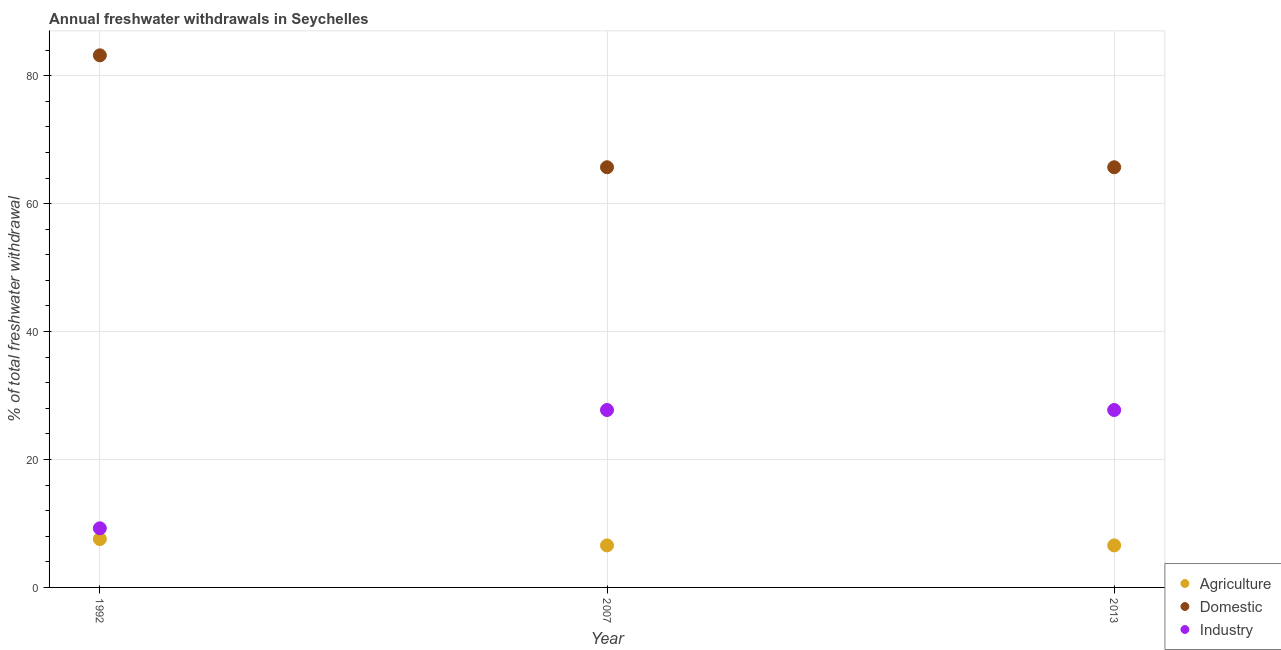Is the number of dotlines equal to the number of legend labels?
Provide a succinct answer. Yes. What is the percentage of freshwater withdrawal for domestic purposes in 2007?
Provide a succinct answer. 65.69. Across all years, what is the maximum percentage of freshwater withdrawal for industry?
Offer a very short reply. 27.74. Across all years, what is the minimum percentage of freshwater withdrawal for agriculture?
Offer a very short reply. 6.57. In which year was the percentage of freshwater withdrawal for domestic purposes maximum?
Provide a short and direct response. 1992. In which year was the percentage of freshwater withdrawal for domestic purposes minimum?
Ensure brevity in your answer.  2007. What is the total percentage of freshwater withdrawal for agriculture in the graph?
Ensure brevity in your answer.  20.7. What is the difference between the percentage of freshwater withdrawal for industry in 1992 and that in 2013?
Your answer should be very brief. -18.5. What is the difference between the percentage of freshwater withdrawal for domestic purposes in 2007 and the percentage of freshwater withdrawal for industry in 1992?
Your answer should be compact. 56.45. What is the average percentage of freshwater withdrawal for industry per year?
Make the answer very short. 21.57. In the year 2007, what is the difference between the percentage of freshwater withdrawal for agriculture and percentage of freshwater withdrawal for industry?
Your answer should be compact. -21.17. What is the ratio of the percentage of freshwater withdrawal for domestic purposes in 1992 to that in 2007?
Provide a succinct answer. 1.27. Is the percentage of freshwater withdrawal for industry in 2007 less than that in 2013?
Keep it short and to the point. No. What is the difference between the highest and the second highest percentage of freshwater withdrawal for agriculture?
Make the answer very short. 0.99. What is the difference between the highest and the lowest percentage of freshwater withdrawal for agriculture?
Provide a succinct answer. 0.99. Is the sum of the percentage of freshwater withdrawal for domestic purposes in 1992 and 2007 greater than the maximum percentage of freshwater withdrawal for agriculture across all years?
Your response must be concise. Yes. Is the percentage of freshwater withdrawal for domestic purposes strictly less than the percentage of freshwater withdrawal for agriculture over the years?
Offer a very short reply. No. Does the graph contain any zero values?
Keep it short and to the point. No. What is the title of the graph?
Provide a succinct answer. Annual freshwater withdrawals in Seychelles. Does "Food" appear as one of the legend labels in the graph?
Give a very brief answer. No. What is the label or title of the X-axis?
Provide a short and direct response. Year. What is the label or title of the Y-axis?
Provide a short and direct response. % of total freshwater withdrawal. What is the % of total freshwater withdrawal of Agriculture in 1992?
Ensure brevity in your answer.  7.56. What is the % of total freshwater withdrawal in Domestic in 1992?
Keep it short and to the point. 83.19. What is the % of total freshwater withdrawal in Industry in 1992?
Ensure brevity in your answer.  9.24. What is the % of total freshwater withdrawal in Agriculture in 2007?
Provide a succinct answer. 6.57. What is the % of total freshwater withdrawal of Domestic in 2007?
Your answer should be very brief. 65.69. What is the % of total freshwater withdrawal in Industry in 2007?
Provide a short and direct response. 27.74. What is the % of total freshwater withdrawal in Agriculture in 2013?
Your response must be concise. 6.57. What is the % of total freshwater withdrawal of Domestic in 2013?
Ensure brevity in your answer.  65.69. What is the % of total freshwater withdrawal of Industry in 2013?
Offer a very short reply. 27.74. Across all years, what is the maximum % of total freshwater withdrawal in Agriculture?
Ensure brevity in your answer.  7.56. Across all years, what is the maximum % of total freshwater withdrawal in Domestic?
Offer a very short reply. 83.19. Across all years, what is the maximum % of total freshwater withdrawal of Industry?
Provide a succinct answer. 27.74. Across all years, what is the minimum % of total freshwater withdrawal in Agriculture?
Keep it short and to the point. 6.57. Across all years, what is the minimum % of total freshwater withdrawal in Domestic?
Make the answer very short. 65.69. Across all years, what is the minimum % of total freshwater withdrawal in Industry?
Keep it short and to the point. 9.24. What is the total % of total freshwater withdrawal in Agriculture in the graph?
Provide a succinct answer. 20.7. What is the total % of total freshwater withdrawal of Domestic in the graph?
Provide a succinct answer. 214.57. What is the total % of total freshwater withdrawal in Industry in the graph?
Offer a very short reply. 64.72. What is the difference between the % of total freshwater withdrawal in Agriculture in 1992 and that in 2007?
Your answer should be compact. 0.99. What is the difference between the % of total freshwater withdrawal in Industry in 1992 and that in 2007?
Offer a terse response. -18.5. What is the difference between the % of total freshwater withdrawal of Industry in 1992 and that in 2013?
Offer a very short reply. -18.5. What is the difference between the % of total freshwater withdrawal in Domestic in 2007 and that in 2013?
Keep it short and to the point. 0. What is the difference between the % of total freshwater withdrawal of Industry in 2007 and that in 2013?
Your answer should be compact. 0. What is the difference between the % of total freshwater withdrawal in Agriculture in 1992 and the % of total freshwater withdrawal in Domestic in 2007?
Make the answer very short. -58.13. What is the difference between the % of total freshwater withdrawal of Agriculture in 1992 and the % of total freshwater withdrawal of Industry in 2007?
Ensure brevity in your answer.  -20.18. What is the difference between the % of total freshwater withdrawal of Domestic in 1992 and the % of total freshwater withdrawal of Industry in 2007?
Offer a very short reply. 55.45. What is the difference between the % of total freshwater withdrawal of Agriculture in 1992 and the % of total freshwater withdrawal of Domestic in 2013?
Offer a terse response. -58.13. What is the difference between the % of total freshwater withdrawal of Agriculture in 1992 and the % of total freshwater withdrawal of Industry in 2013?
Keep it short and to the point. -20.18. What is the difference between the % of total freshwater withdrawal of Domestic in 1992 and the % of total freshwater withdrawal of Industry in 2013?
Your answer should be compact. 55.45. What is the difference between the % of total freshwater withdrawal in Agriculture in 2007 and the % of total freshwater withdrawal in Domestic in 2013?
Offer a terse response. -59.12. What is the difference between the % of total freshwater withdrawal in Agriculture in 2007 and the % of total freshwater withdrawal in Industry in 2013?
Provide a short and direct response. -21.17. What is the difference between the % of total freshwater withdrawal of Domestic in 2007 and the % of total freshwater withdrawal of Industry in 2013?
Give a very brief answer. 37.95. What is the average % of total freshwater withdrawal in Agriculture per year?
Provide a succinct answer. 6.9. What is the average % of total freshwater withdrawal in Domestic per year?
Your response must be concise. 71.52. What is the average % of total freshwater withdrawal of Industry per year?
Ensure brevity in your answer.  21.57. In the year 1992, what is the difference between the % of total freshwater withdrawal in Agriculture and % of total freshwater withdrawal in Domestic?
Offer a terse response. -75.63. In the year 1992, what is the difference between the % of total freshwater withdrawal of Agriculture and % of total freshwater withdrawal of Industry?
Provide a succinct answer. -1.68. In the year 1992, what is the difference between the % of total freshwater withdrawal of Domestic and % of total freshwater withdrawal of Industry?
Provide a succinct answer. 73.95. In the year 2007, what is the difference between the % of total freshwater withdrawal of Agriculture and % of total freshwater withdrawal of Domestic?
Keep it short and to the point. -59.12. In the year 2007, what is the difference between the % of total freshwater withdrawal of Agriculture and % of total freshwater withdrawal of Industry?
Ensure brevity in your answer.  -21.17. In the year 2007, what is the difference between the % of total freshwater withdrawal of Domestic and % of total freshwater withdrawal of Industry?
Your response must be concise. 37.95. In the year 2013, what is the difference between the % of total freshwater withdrawal in Agriculture and % of total freshwater withdrawal in Domestic?
Keep it short and to the point. -59.12. In the year 2013, what is the difference between the % of total freshwater withdrawal in Agriculture and % of total freshwater withdrawal in Industry?
Ensure brevity in your answer.  -21.17. In the year 2013, what is the difference between the % of total freshwater withdrawal in Domestic and % of total freshwater withdrawal in Industry?
Your answer should be compact. 37.95. What is the ratio of the % of total freshwater withdrawal of Agriculture in 1992 to that in 2007?
Give a very brief answer. 1.15. What is the ratio of the % of total freshwater withdrawal in Domestic in 1992 to that in 2007?
Provide a succinct answer. 1.27. What is the ratio of the % of total freshwater withdrawal in Industry in 1992 to that in 2007?
Provide a succinct answer. 0.33. What is the ratio of the % of total freshwater withdrawal of Agriculture in 1992 to that in 2013?
Keep it short and to the point. 1.15. What is the ratio of the % of total freshwater withdrawal of Domestic in 1992 to that in 2013?
Your response must be concise. 1.27. What is the ratio of the % of total freshwater withdrawal of Industry in 1992 to that in 2013?
Keep it short and to the point. 0.33. What is the ratio of the % of total freshwater withdrawal of Industry in 2007 to that in 2013?
Ensure brevity in your answer.  1. What is the difference between the highest and the second highest % of total freshwater withdrawal in Domestic?
Offer a terse response. 17.5. What is the difference between the highest and the second highest % of total freshwater withdrawal of Industry?
Your response must be concise. 0. What is the difference between the highest and the lowest % of total freshwater withdrawal in Agriculture?
Your answer should be very brief. 0.99. What is the difference between the highest and the lowest % of total freshwater withdrawal in Domestic?
Provide a short and direct response. 17.5. What is the difference between the highest and the lowest % of total freshwater withdrawal in Industry?
Your answer should be compact. 18.5. 